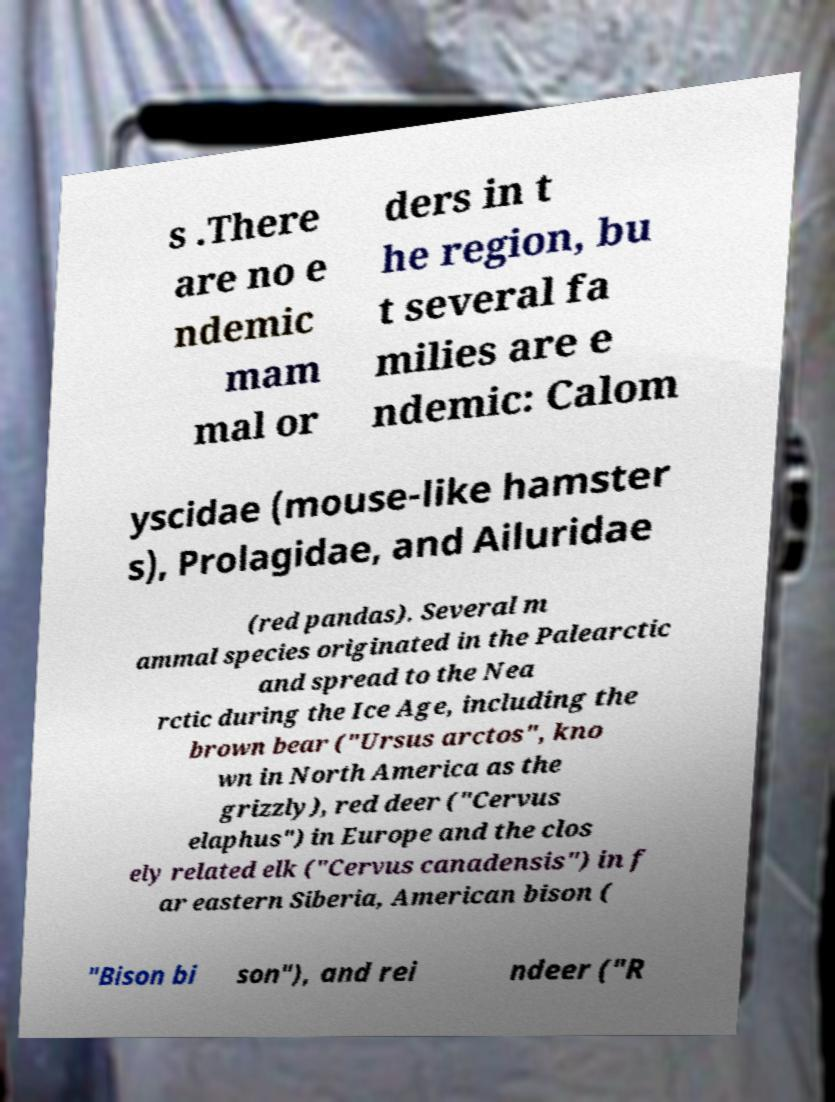I need the written content from this picture converted into text. Can you do that? s .There are no e ndemic mam mal or ders in t he region, bu t several fa milies are e ndemic: Calom yscidae (mouse-like hamster s), Prolagidae, and Ailuridae (red pandas). Several m ammal species originated in the Palearctic and spread to the Nea rctic during the Ice Age, including the brown bear ("Ursus arctos", kno wn in North America as the grizzly), red deer ("Cervus elaphus") in Europe and the clos ely related elk ("Cervus canadensis") in f ar eastern Siberia, American bison ( "Bison bi son"), and rei ndeer ("R 